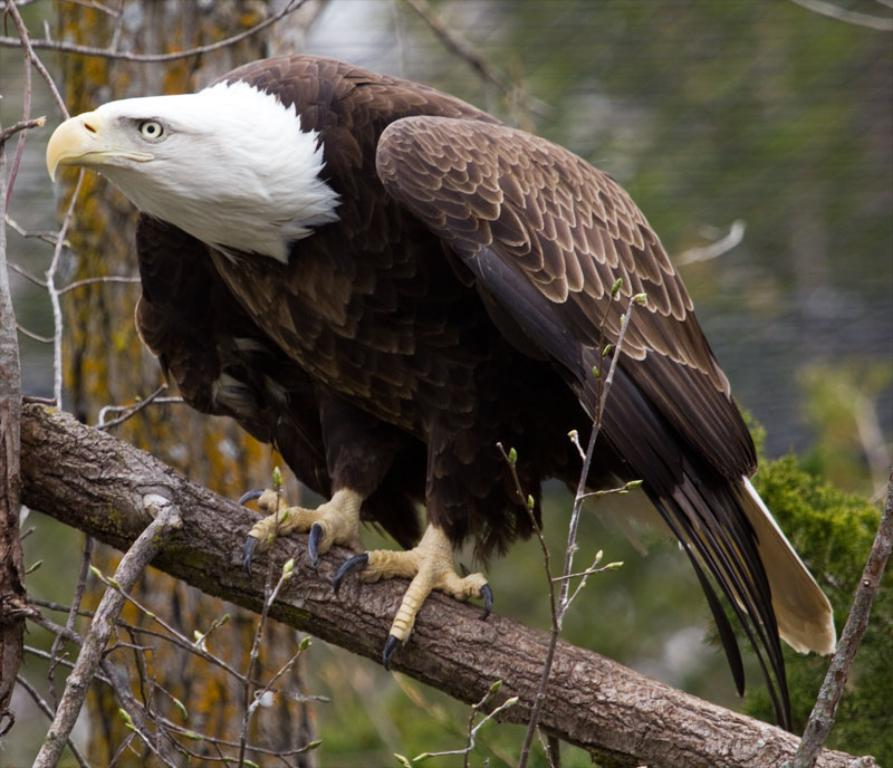What animal is featured in the image? There is an eagle in the image. Where is the eagle located? The eagle is on a tree in the image. What type of plant is present in the image? There is a tree in the image. Can you describe the background of the image? The background of the image is blurred. What month is it in the image? The month is not mentioned or depicted in the image, so it cannot be determined. How many boys are visible in the image? There are no boys present in the image; it features an eagle on a tree. 